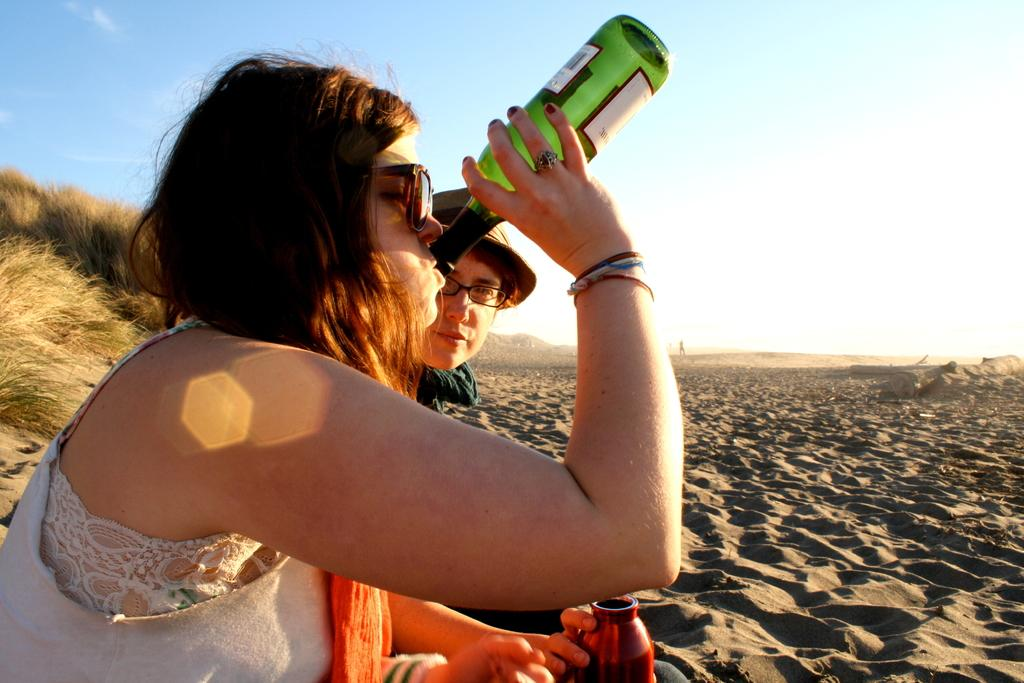Who is the main subject in the image? There is a lady in the image. What is the lady holding in the image? The lady is holding a bottle. What is the lady doing with the bottle? The lady is drinking from the bottle. Can you describe the person sitting on the sand? The person is wearing spectacles. What is the background of the image like? There is grass visible in the background of the image. What type of station can be seen in the image? There is no station present in the image. What kind of rod is being used by the lady in the image? The lady is not using any rod in the image; she is drinking from a bottle. 